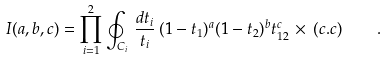<formula> <loc_0><loc_0><loc_500><loc_500>I ( a , b , c ) = \prod _ { i = 1 } ^ { 2 } \oint _ { C _ { i } } \, \frac { d t _ { i } } { t _ { i } } \, ( 1 - t _ { 1 } ) ^ { a } ( 1 - t _ { 2 } ) ^ { b } t _ { 1 2 } ^ { c } \, \times \, ( c . c ) \quad .</formula> 